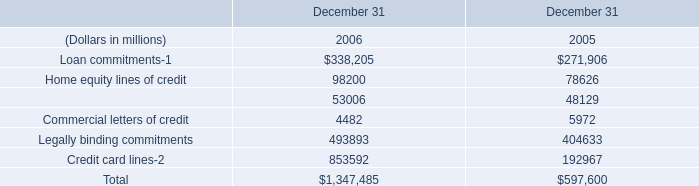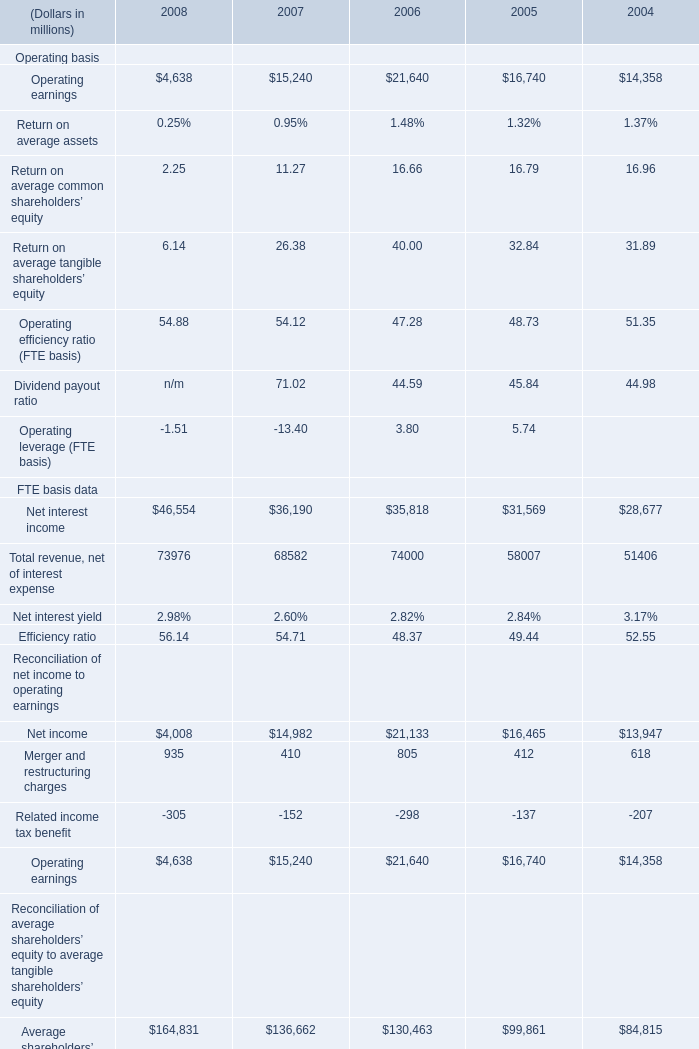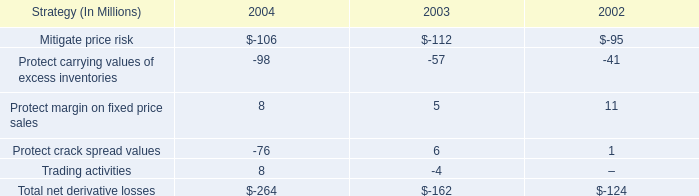In the year with the most Net interest income in table 1, what is the growth rate of Net income in table 1? 
Computations: ((4008 - 14982) / 14982)
Answer: -0.73248. 